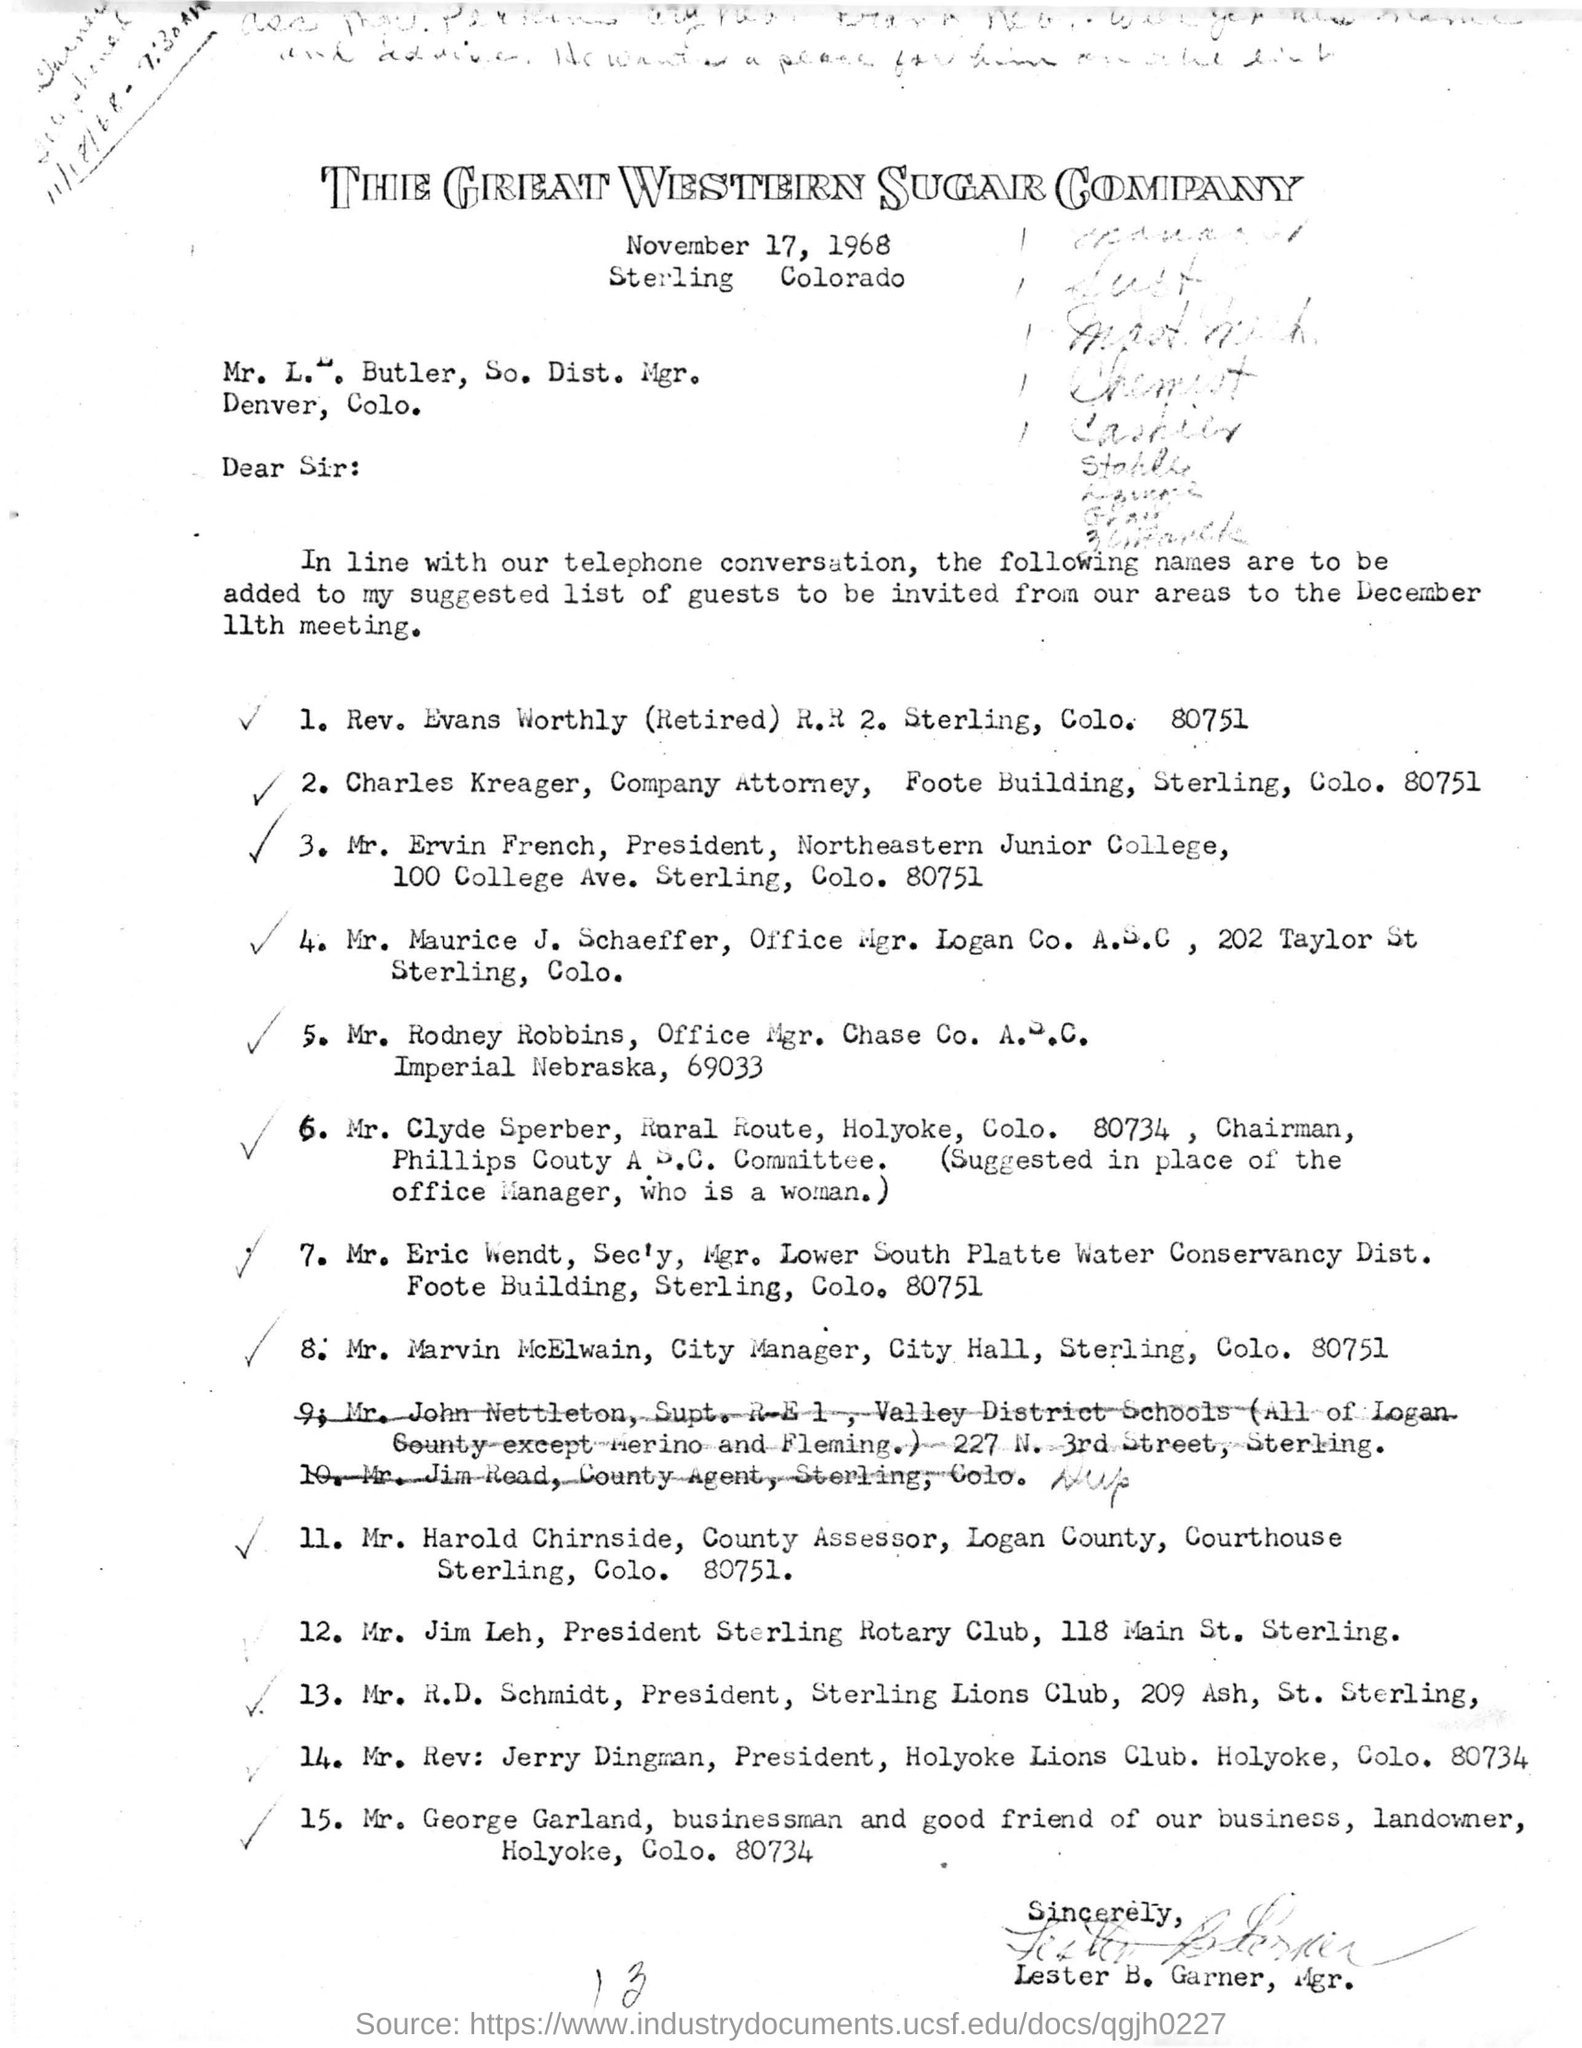Name of the company attorney
Ensure brevity in your answer.  Charles kreager. Who is the president of northeastern junior college
Your answer should be compact. Mr Ervin French. 